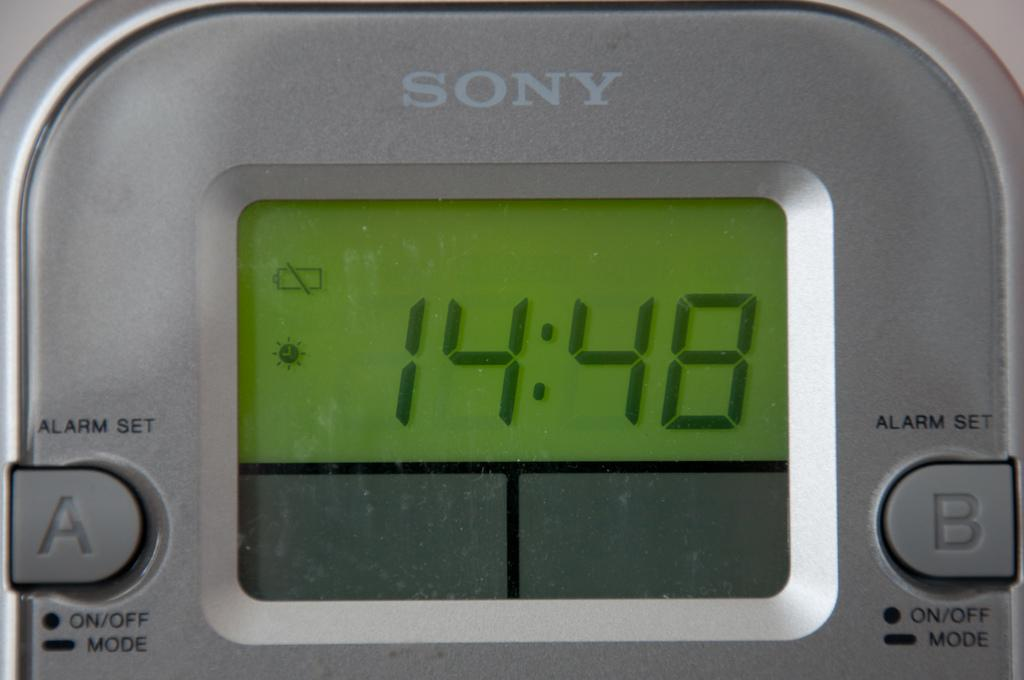<image>
Describe the image concisely. the time on the Sony device is 14:48 